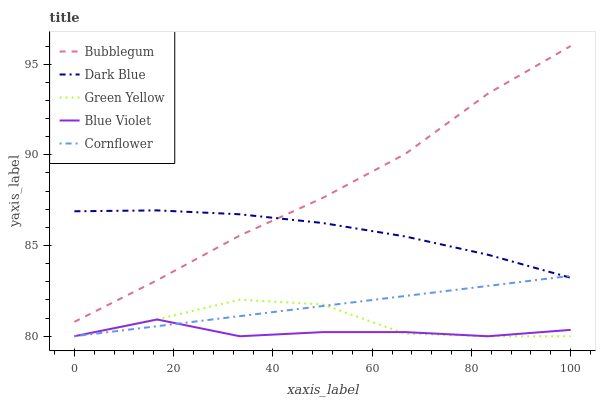Does Blue Violet have the minimum area under the curve?
Answer yes or no. Yes. Does Bubblegum have the maximum area under the curve?
Answer yes or no. Yes. Does Green Yellow have the minimum area under the curve?
Answer yes or no. No. Does Green Yellow have the maximum area under the curve?
Answer yes or no. No. Is Cornflower the smoothest?
Answer yes or no. Yes. Is Green Yellow the roughest?
Answer yes or no. Yes. Is Blue Violet the smoothest?
Answer yes or no. No. Is Blue Violet the roughest?
Answer yes or no. No. Does Green Yellow have the lowest value?
Answer yes or no. Yes. Does Bubblegum have the lowest value?
Answer yes or no. No. Does Bubblegum have the highest value?
Answer yes or no. Yes. Does Green Yellow have the highest value?
Answer yes or no. No. Is Cornflower less than Bubblegum?
Answer yes or no. Yes. Is Dark Blue greater than Green Yellow?
Answer yes or no. Yes. Does Bubblegum intersect Dark Blue?
Answer yes or no. Yes. Is Bubblegum less than Dark Blue?
Answer yes or no. No. Is Bubblegum greater than Dark Blue?
Answer yes or no. No. Does Cornflower intersect Bubblegum?
Answer yes or no. No. 